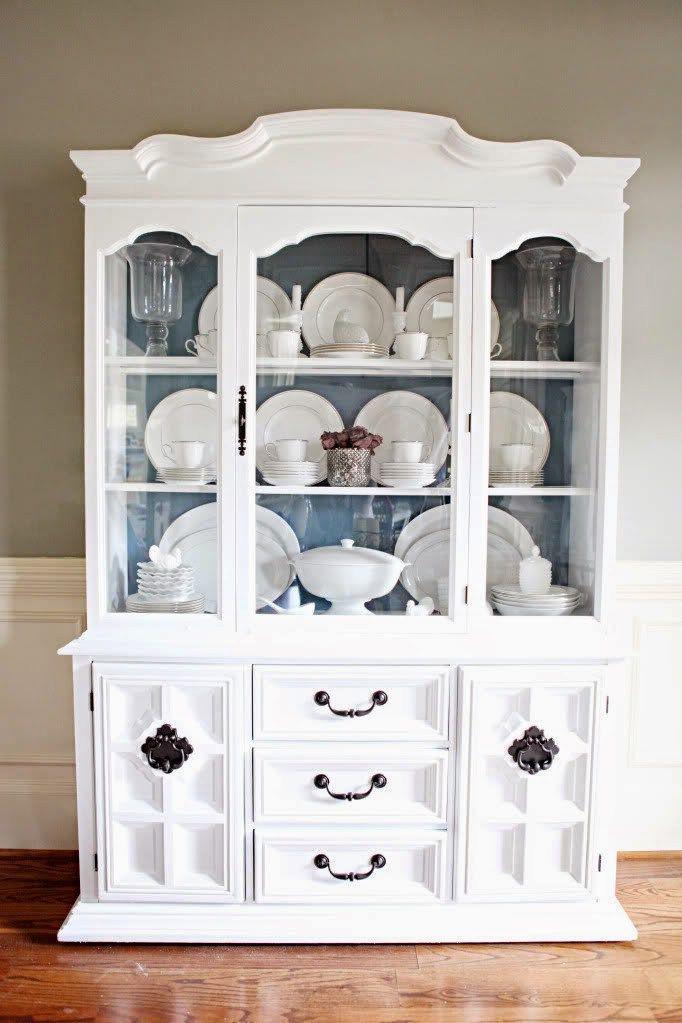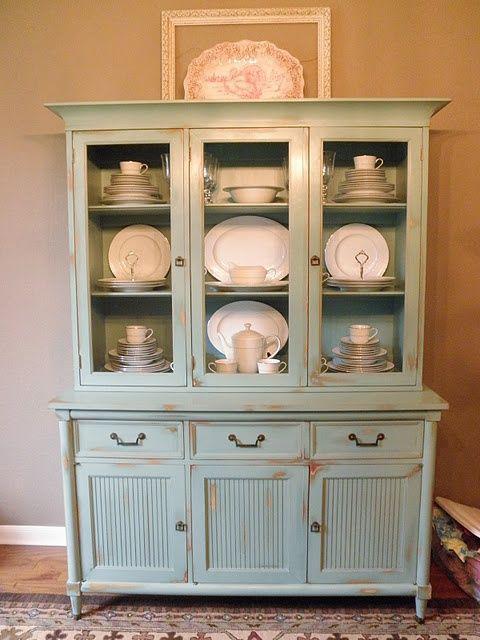The first image is the image on the left, the second image is the image on the right. Analyze the images presented: Is the assertion "One cabinet is white with a pale blue interior and sculpted, non-flat top, and sits flush to the floor." valid? Answer yes or no. Yes. The first image is the image on the left, the second image is the image on the right. Examine the images to the left and right. Is the description "There are two freestanding cabinets containing dishes." accurate? Answer yes or no. Yes. 